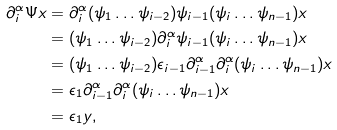Convert formula to latex. <formula><loc_0><loc_0><loc_500><loc_500>\partial _ { i } ^ { \alpha } \Psi x & = \partial _ { i } ^ { \alpha } ( \psi _ { 1 } \dots \psi _ { i - 2 } ) \psi _ { i - 1 } ( \psi _ { i } \dots \psi _ { n - 1 } ) x \\ & = ( \psi _ { 1 } \dots \psi _ { i - 2 } ) \partial _ { i } ^ { \alpha } \psi _ { i - 1 } ( \psi _ { i } \dots \psi _ { n - 1 } ) x \\ & = ( \psi _ { 1 } \dots \psi _ { i - 2 } ) \epsilon _ { i - 1 } \partial _ { i - 1 } ^ { \alpha } \partial _ { i } ^ { \alpha } ( \psi _ { i } \dots \psi _ { n - 1 } ) x \\ & = \epsilon _ { 1 } \partial _ { i - 1 } ^ { \alpha } \partial _ { i } ^ { \alpha } ( \psi _ { i } \dots \psi _ { n - 1 } ) x \\ & = \epsilon _ { 1 } y ,</formula> 